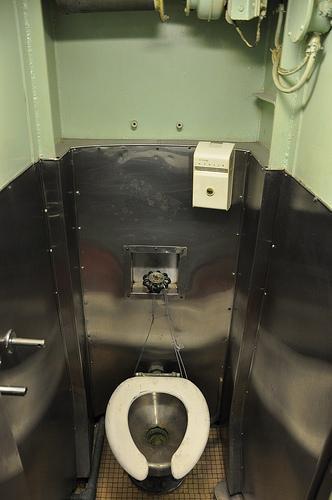How many walls are there?
Give a very brief answer. 3. How many neon green toilet seats are there?
Give a very brief answer. 0. 